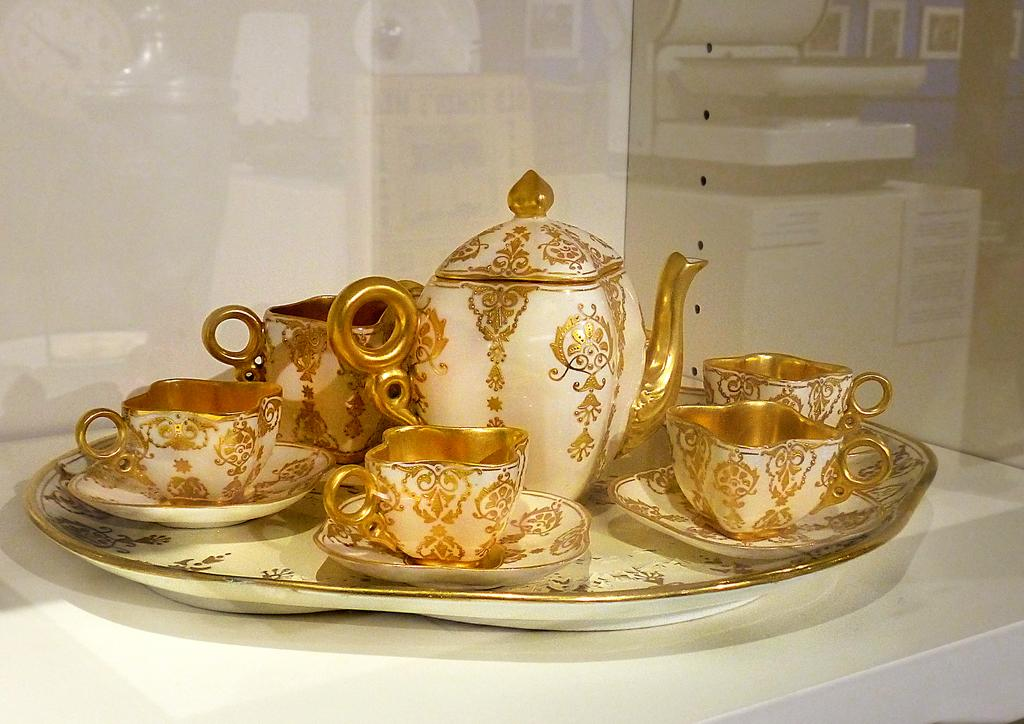What is the color of the surface in the image? The surface in the image is white. What is placed on the white surface? There is a tray on the white surface. What items are on the tray? There are cups, saucers, and a kettle on the tray. What type of card is being used to support the kettle on the image? There is no card present in the image, and the kettle is not being supported by any card. 